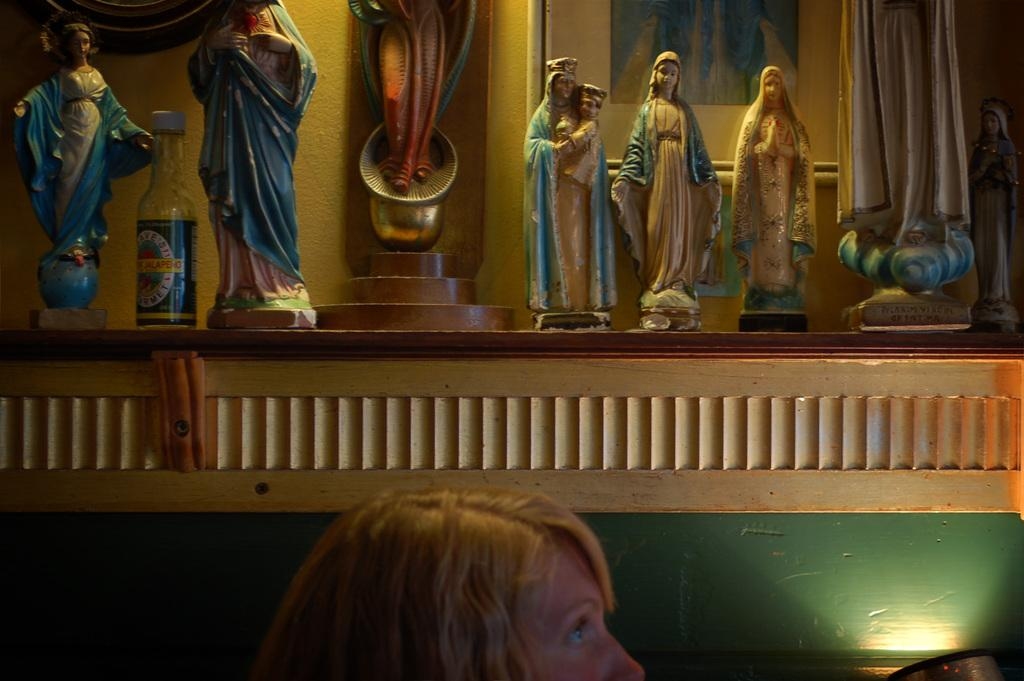What color is the wall that can be seen in the image? The wall in the image is yellow. What objects are present in the image besides the wall? There are statues and a bottle visible in the image. Can you describe the woman's face that is visible in the image? A woman's face is visible in the front of the image. What type of support can be seen holding up the ship in the image? There is no ship present in the image, so there is no support for a ship. What key is used to unlock the door in the image? There is no door or key present in the image. 